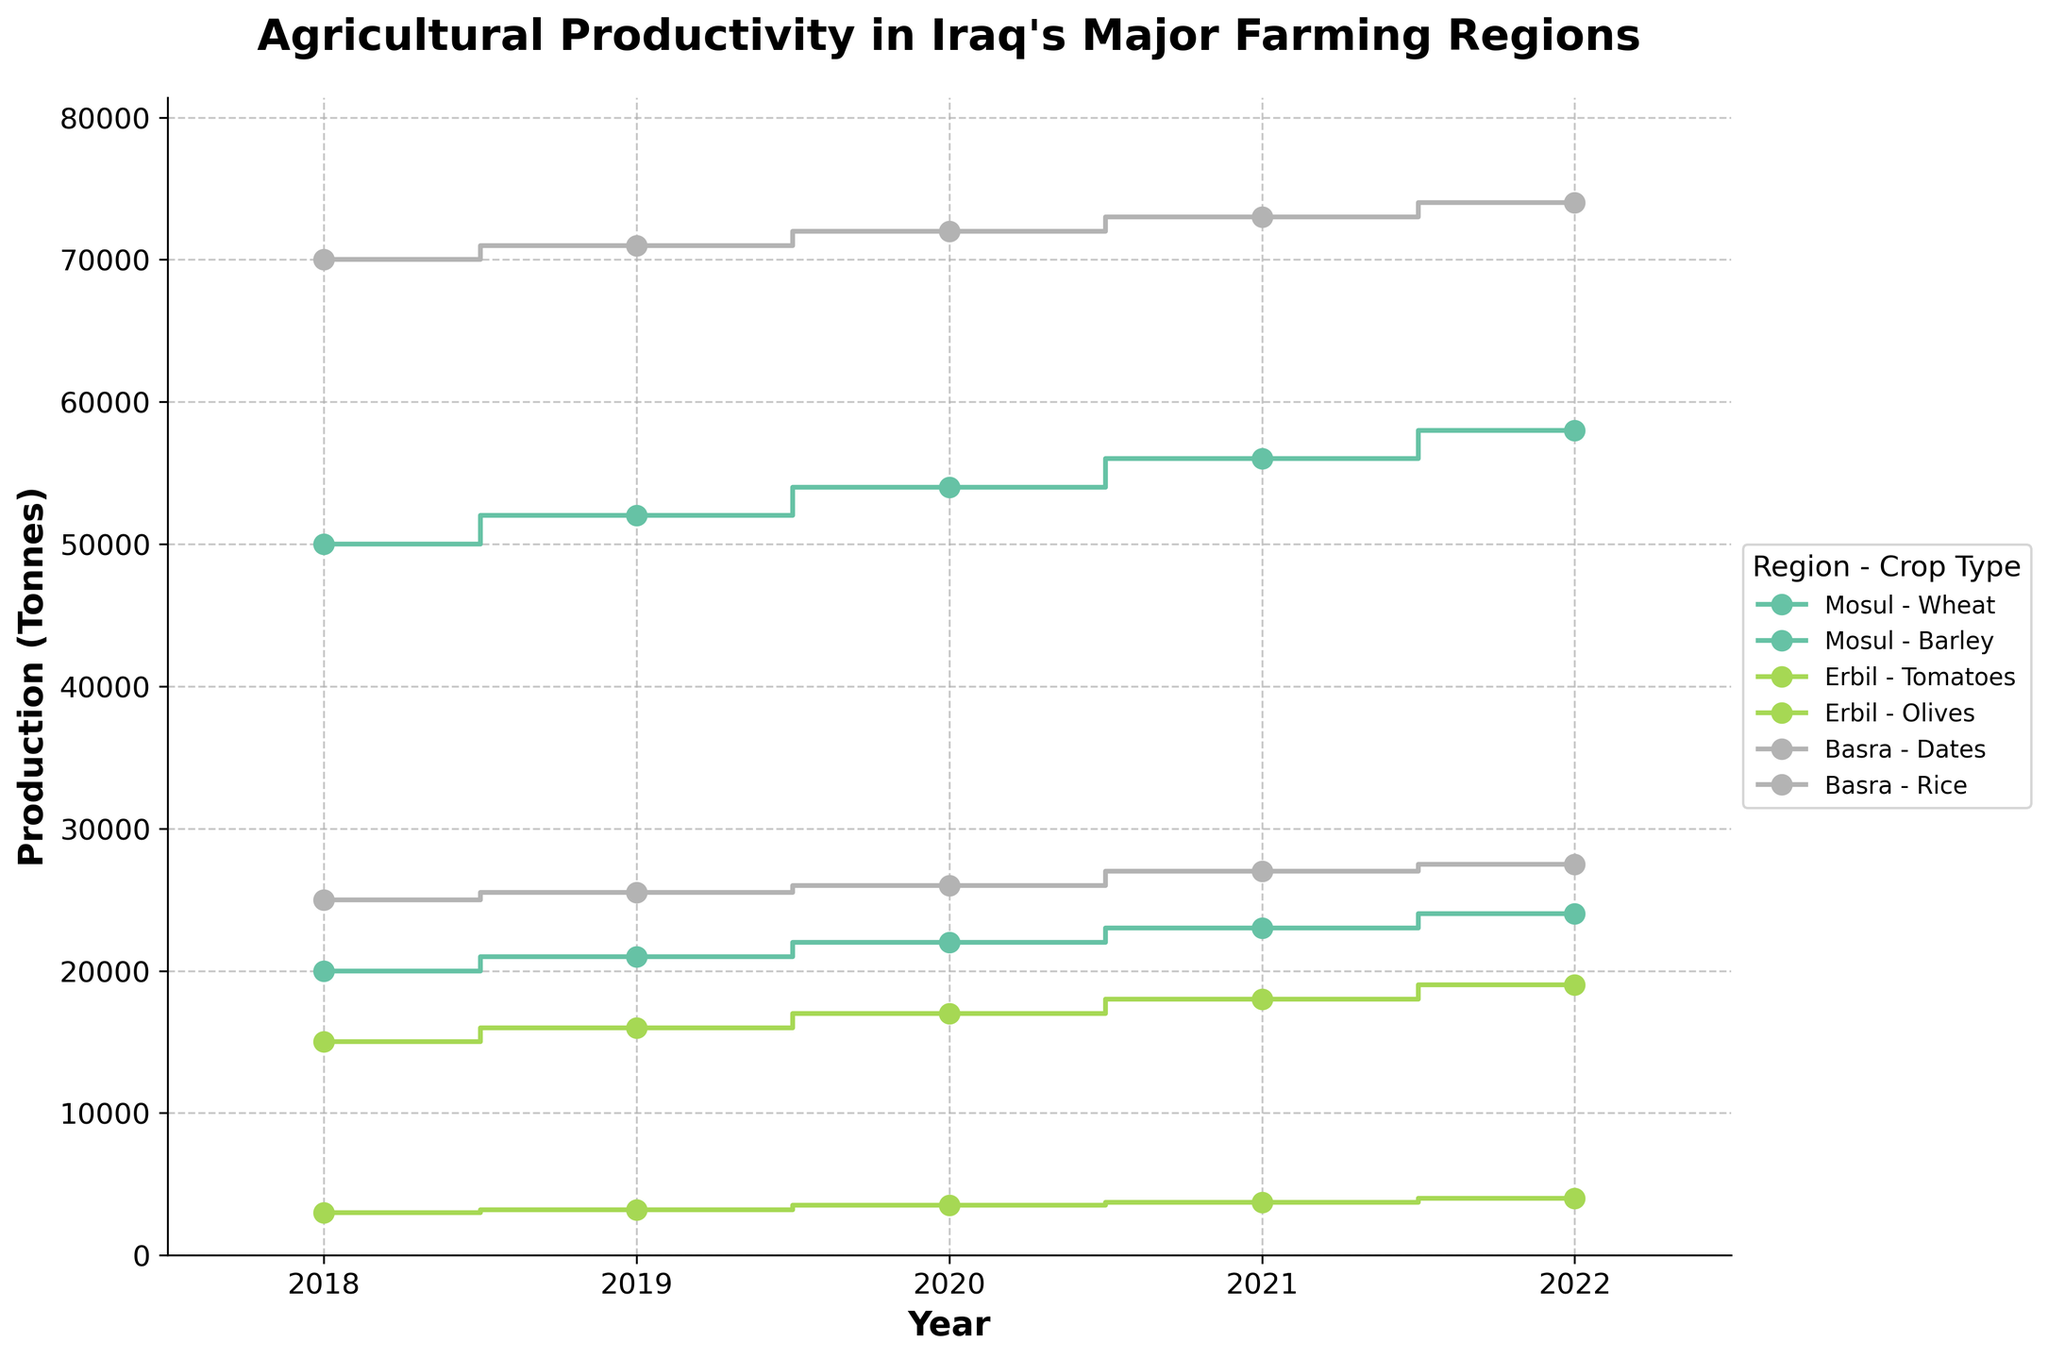what is the title of the figure? The title of a figure is typically located at the top and is used to give an overview of what the figure represents. In this case, the title of the figure is displayed prominently at the top center, stating the main focus of the data plotted.
Answer: Agricultural Productivity in Iraq's Major Farming Regions what crops are produced in Erbil? By examining the region-specific sections of the plot, we observe the crops listed under Erbil, signified by distinct colors and markers for each region and crop type.
Answer: Tomatoes and Olives During which year did Mosul produce 56,000 tonnes of wheat? The step plot visually presents the data points for each year, where we can trace the quantity of wheat produced in Mosul over the years and identify the corresponding year's data value of 56,000 tonnes.
Answer: 2021 what is the trend in the production of Dates in Basra from 2018 to 2022? By following the plotted line for Dates in Basra over the years 2018 to 2022, we can observe the annual ups and downs or consistent increase/decrease and determine the trend of the production figures.
Answer: Increasing which combination of region and crop type had the highest production in any given year? We need to look at all the steps and determine the plot with the highest peak, indicating the maximum production for any region and crop type over the timeframe of the figure.
Answer: Basra - Dates what is the difference in tomato production between 2018 and 2022 in Erbil? Subtract the production value of tomatoes in Erbil for the year 2018 from the production value of tomatoes in Erbil for the year 2022 as shown on the plot to find the difference.
Answer: 4000 tonnes compare the production of rice in Basra between 2019 and 2021. Which year had higher production? By observing the steps for rice in Basra over the years 2019 and 2021, we can compare the respective production values and determine which year shows a higher figure.
Answer: 2021 How does the production of barley in Mosul change over the years depicted in the plot? Follow the step line associated with barley in Mosul, noting the production amount at each year’s marker to describe the changes in production amount over time.
Answer: Increasing steadily which region experienced the least variation in crop production between 2018 and 2022? By examining the smoothness and stability of the step plots for different regions and the many ups and downs, we can identify which region had its production figures most stable with minimal fluctuations.
Answer: Basra 